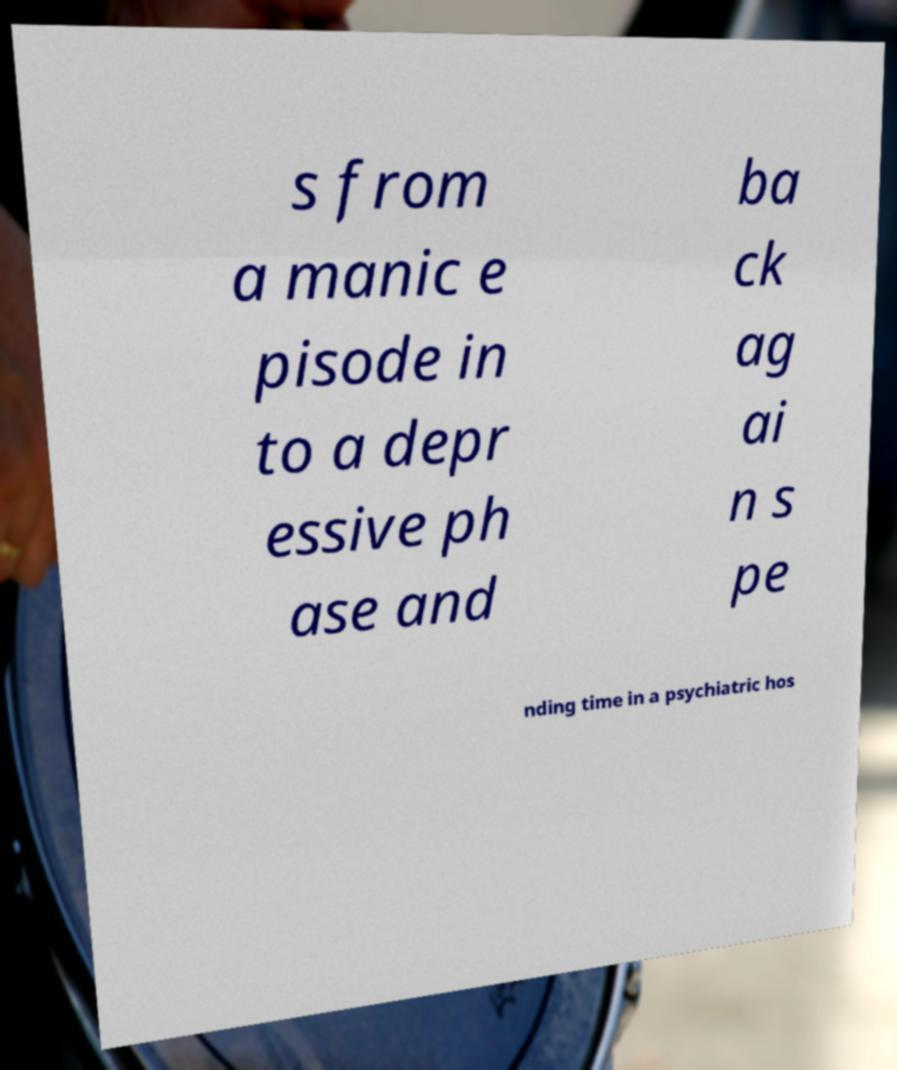Can you accurately transcribe the text from the provided image for me? s from a manic e pisode in to a depr essive ph ase and ba ck ag ai n s pe nding time in a psychiatric hos 